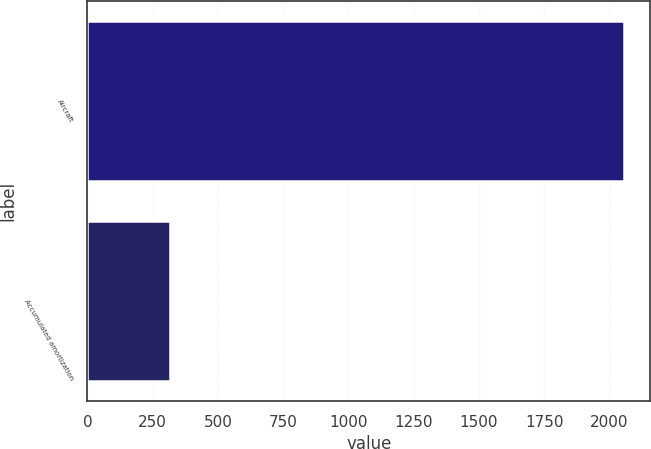<chart> <loc_0><loc_0><loc_500><loc_500><bar_chart><fcel>Aircraft<fcel>Accumulated amortization<nl><fcel>2054<fcel>315<nl></chart> 